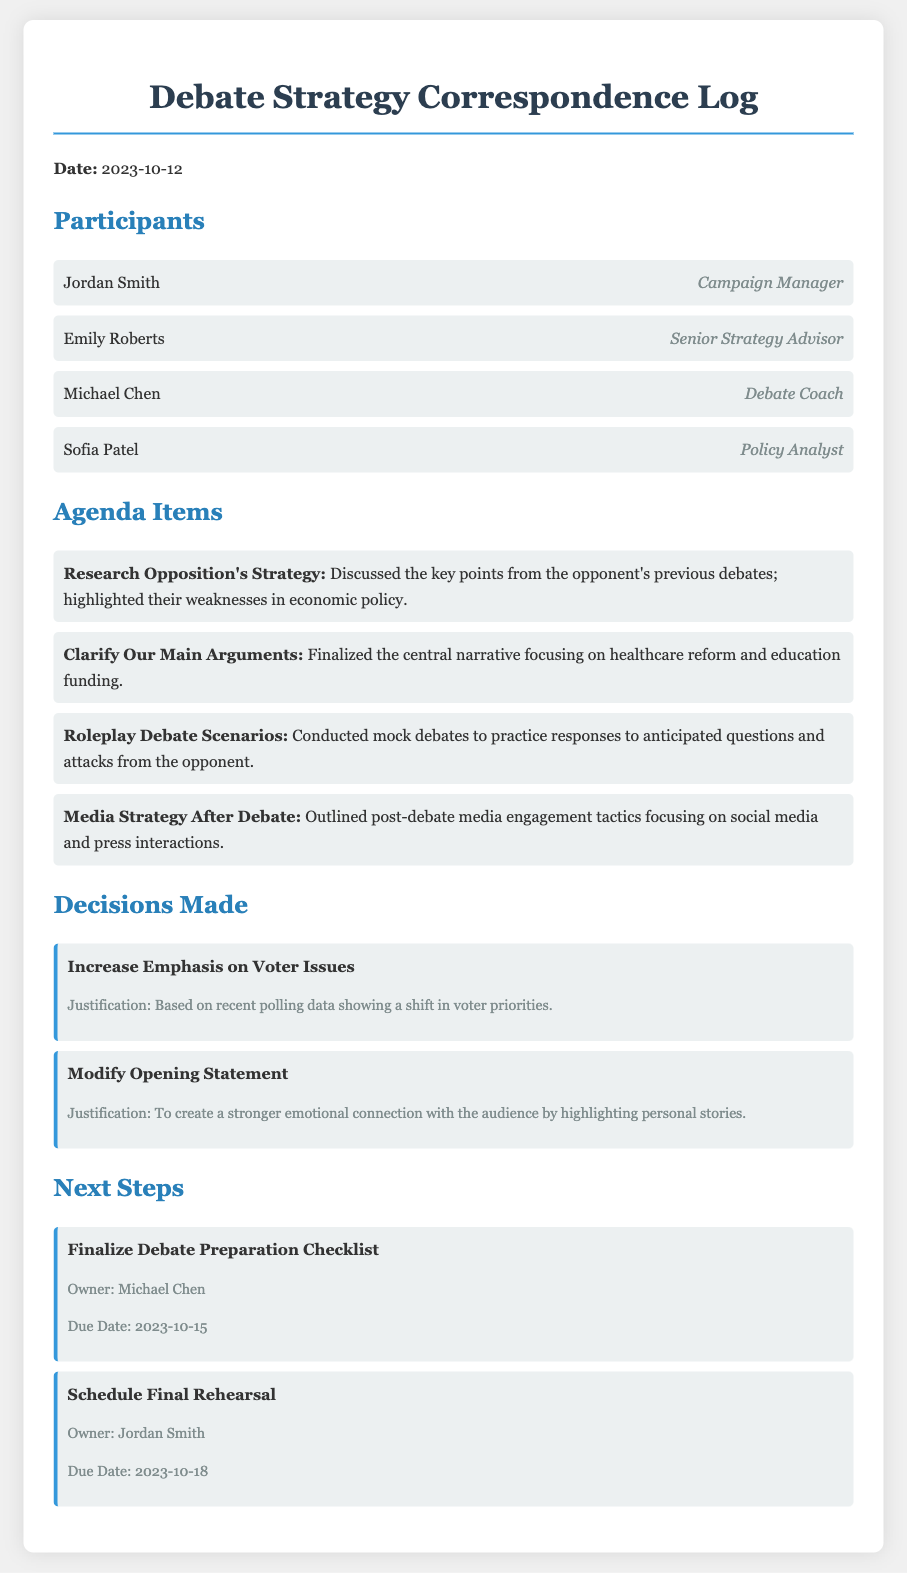What is the date of the correspondence log? The date is explicitly stated at the beginning of the log.
Answer: 2023-10-12 Who is the Campaign Manager? The role of Campaign Manager is assigned to Jordan Smith in the list of participants.
Answer: Jordan Smith What was one of the agenda items discussed? The agenda items outlined a few key activities; any of them will suffice, but one specific item was explicitly mentioned.
Answer: Research Opposition's Strategy What decision was made regarding the opening statement? The document lists specific decisions made, including one about the opening statement.
Answer: Modify Opening Statement Who is responsible for finalizing the debate preparation checklist? The next steps include an action item assigned to an individual, where the owner is clearly stated.
Answer: Michael Chen What is one key issue of emphasis based on recent polling data? The decisions made section elaborated on the emphasis to be placed on voter issues according to recent polling findings.
Answer: Voter Issues How many participants were involved in the closed-door meeting? The participant list shows a specific number of individuals in attendance.
Answer: Four What is the due date for scheduling the final rehearsal? Each next step item includes a due date, which is clearly stated for the rehearsal.
Answer: 2023-10-18 What was emphasized in the justification for increasing the emphasis on voter issues? The justification provides context for the decision made, referencing specific supporting information.
Answer: Recent polling data 